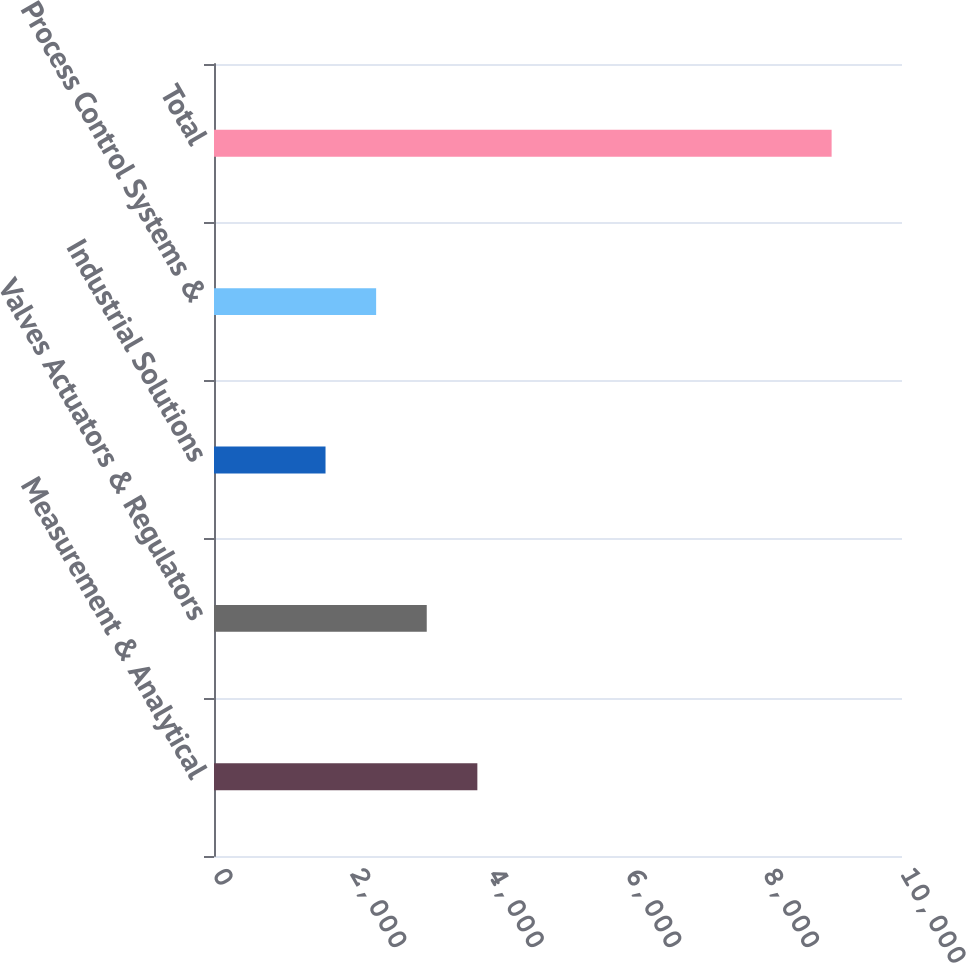<chart> <loc_0><loc_0><loc_500><loc_500><bar_chart><fcel>Measurement & Analytical<fcel>Valves Actuators & Regulators<fcel>Industrial Solutions<fcel>Process Control Systems &<fcel>Total<nl><fcel>3827.8<fcel>3092.2<fcel>1621<fcel>2356.6<fcel>8977<nl></chart> 